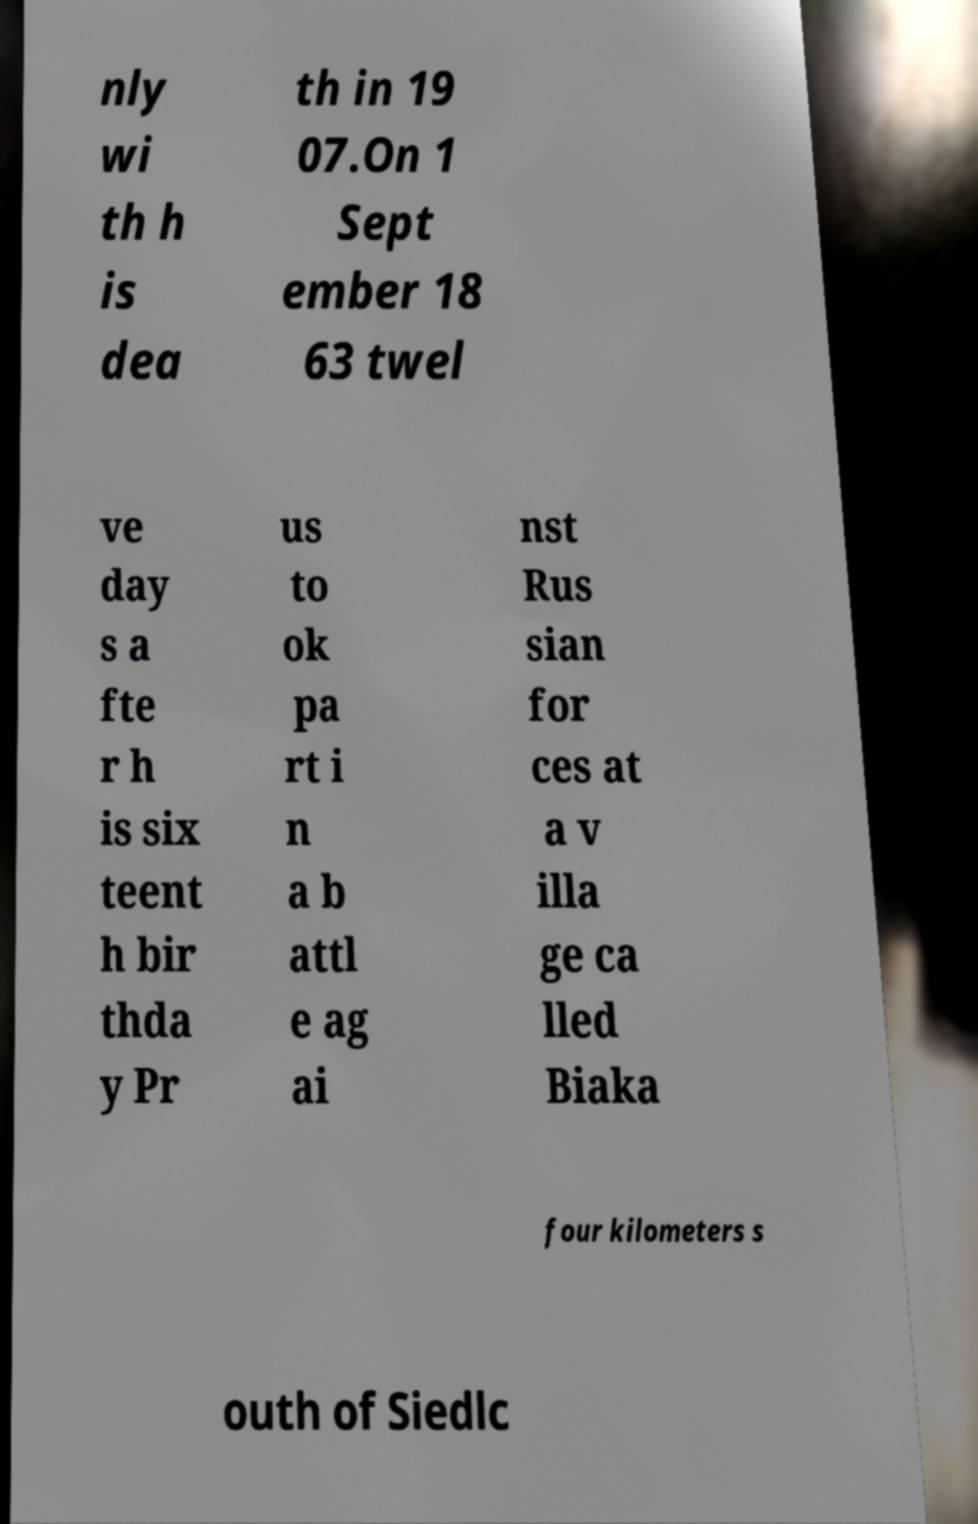Can you read and provide the text displayed in the image?This photo seems to have some interesting text. Can you extract and type it out for me? nly wi th h is dea th in 19 07.On 1 Sept ember 18 63 twel ve day s a fte r h is six teent h bir thda y Pr us to ok pa rt i n a b attl e ag ai nst Rus sian for ces at a v illa ge ca lled Biaka four kilometers s outh of Siedlc 